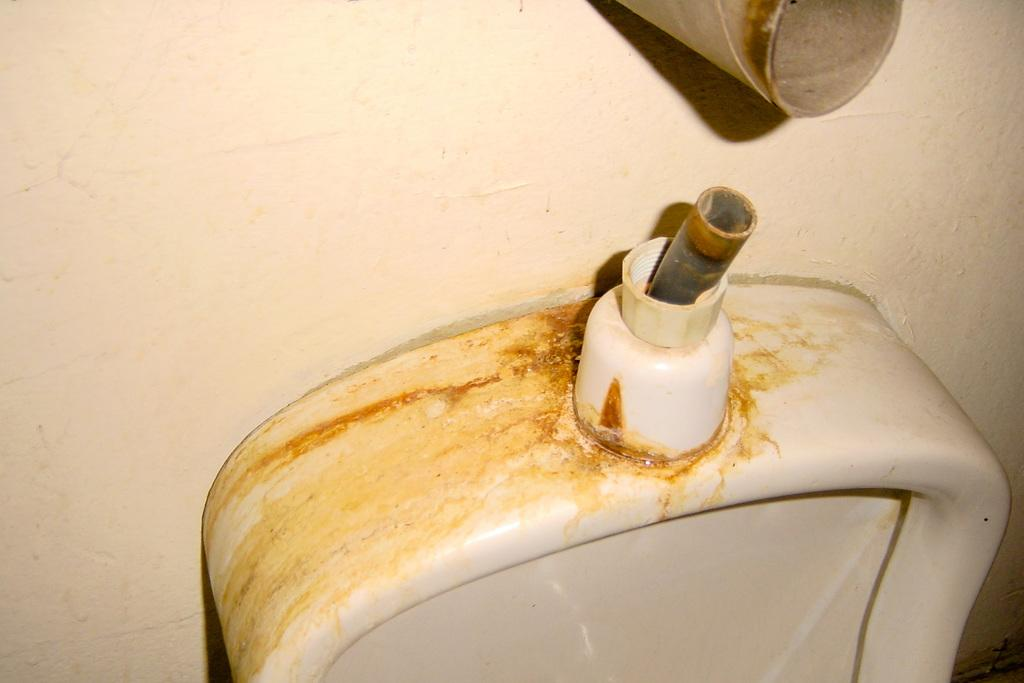What type of structure can be seen in the image? There is a wall in the image. What is located near the wall in the image? There is a urinal seat in the image. Is there anything attached to the wall in the image? Yes, there is an object on the wall in the image. What color is the sock hanging on the frame in the image? There is no sock or frame present in the image. What type of material is the brass object on the wall made of in the image? There is no brass object mentioned in the provided facts, so we cannot answer this question. 